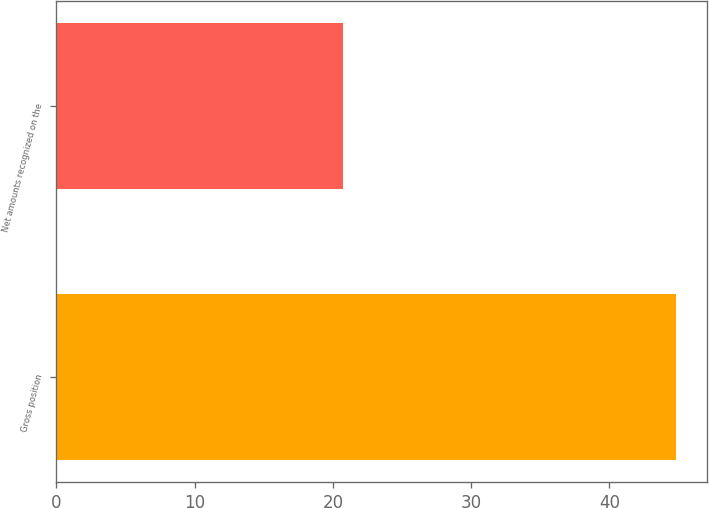Convert chart. <chart><loc_0><loc_0><loc_500><loc_500><bar_chart><fcel>Gross position<fcel>Net amounts recognized on the<nl><fcel>44.8<fcel>20.7<nl></chart> 